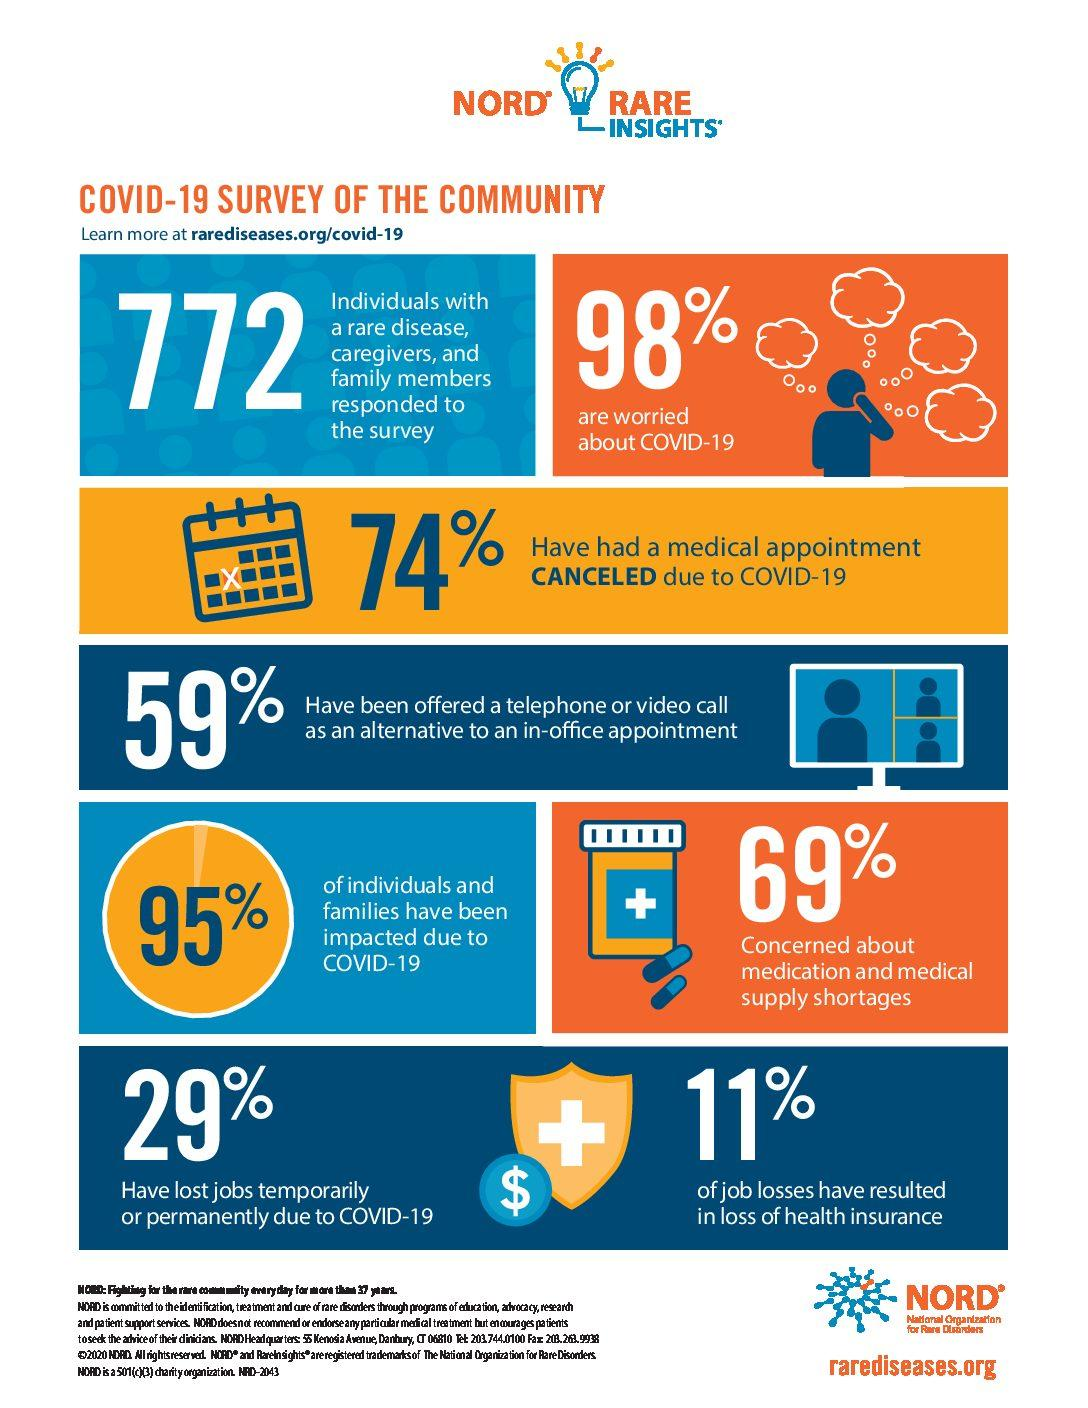Outline some significant characteristics in this image. A survey found that 41% of people have not been offered the option of a telephone or video call as an alternative to an in-office appointment. A small percentage of individuals and families, approximately 5%, have not been affected by COVID-19. During the COVID-19 pandemic, it is estimated that approximately 26% of people have had a medical appointment. A recent survey found that 31% of people are not concerned about medication and medical supply shortages. According to recent data, only 2% of people are not worried about Covid-19. 